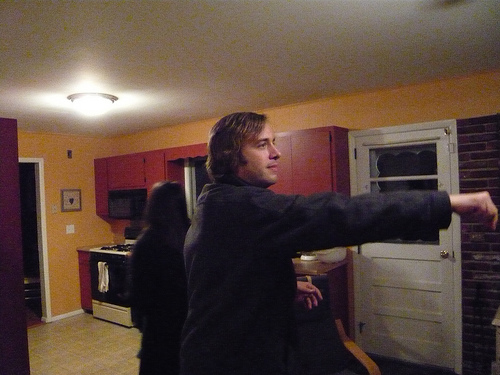<image>
Is the light in the man? No. The light is not contained within the man. These objects have a different spatial relationship. 